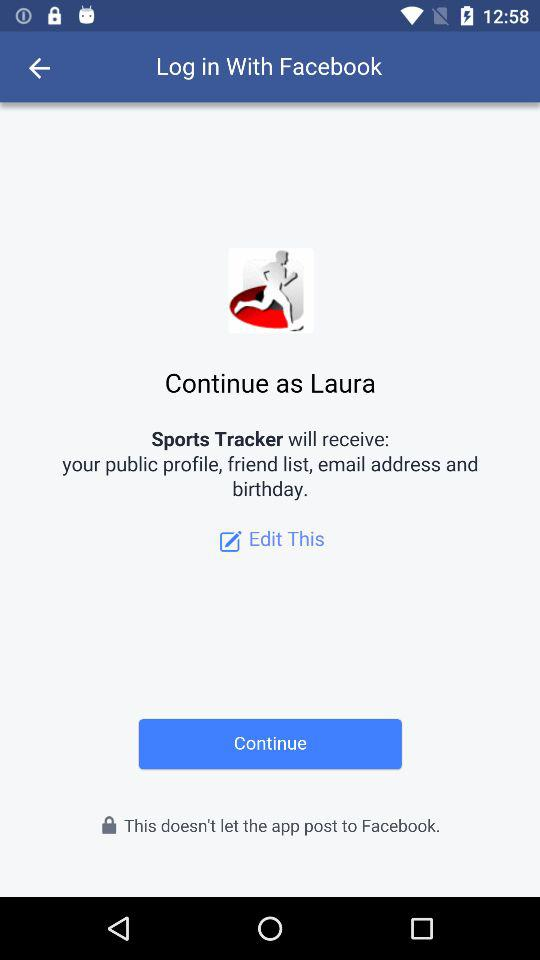Who will receive the public profile, friend list, email address and birthday? The public profile, friend list, email address and birthday will be received by "Sports Tracker". 